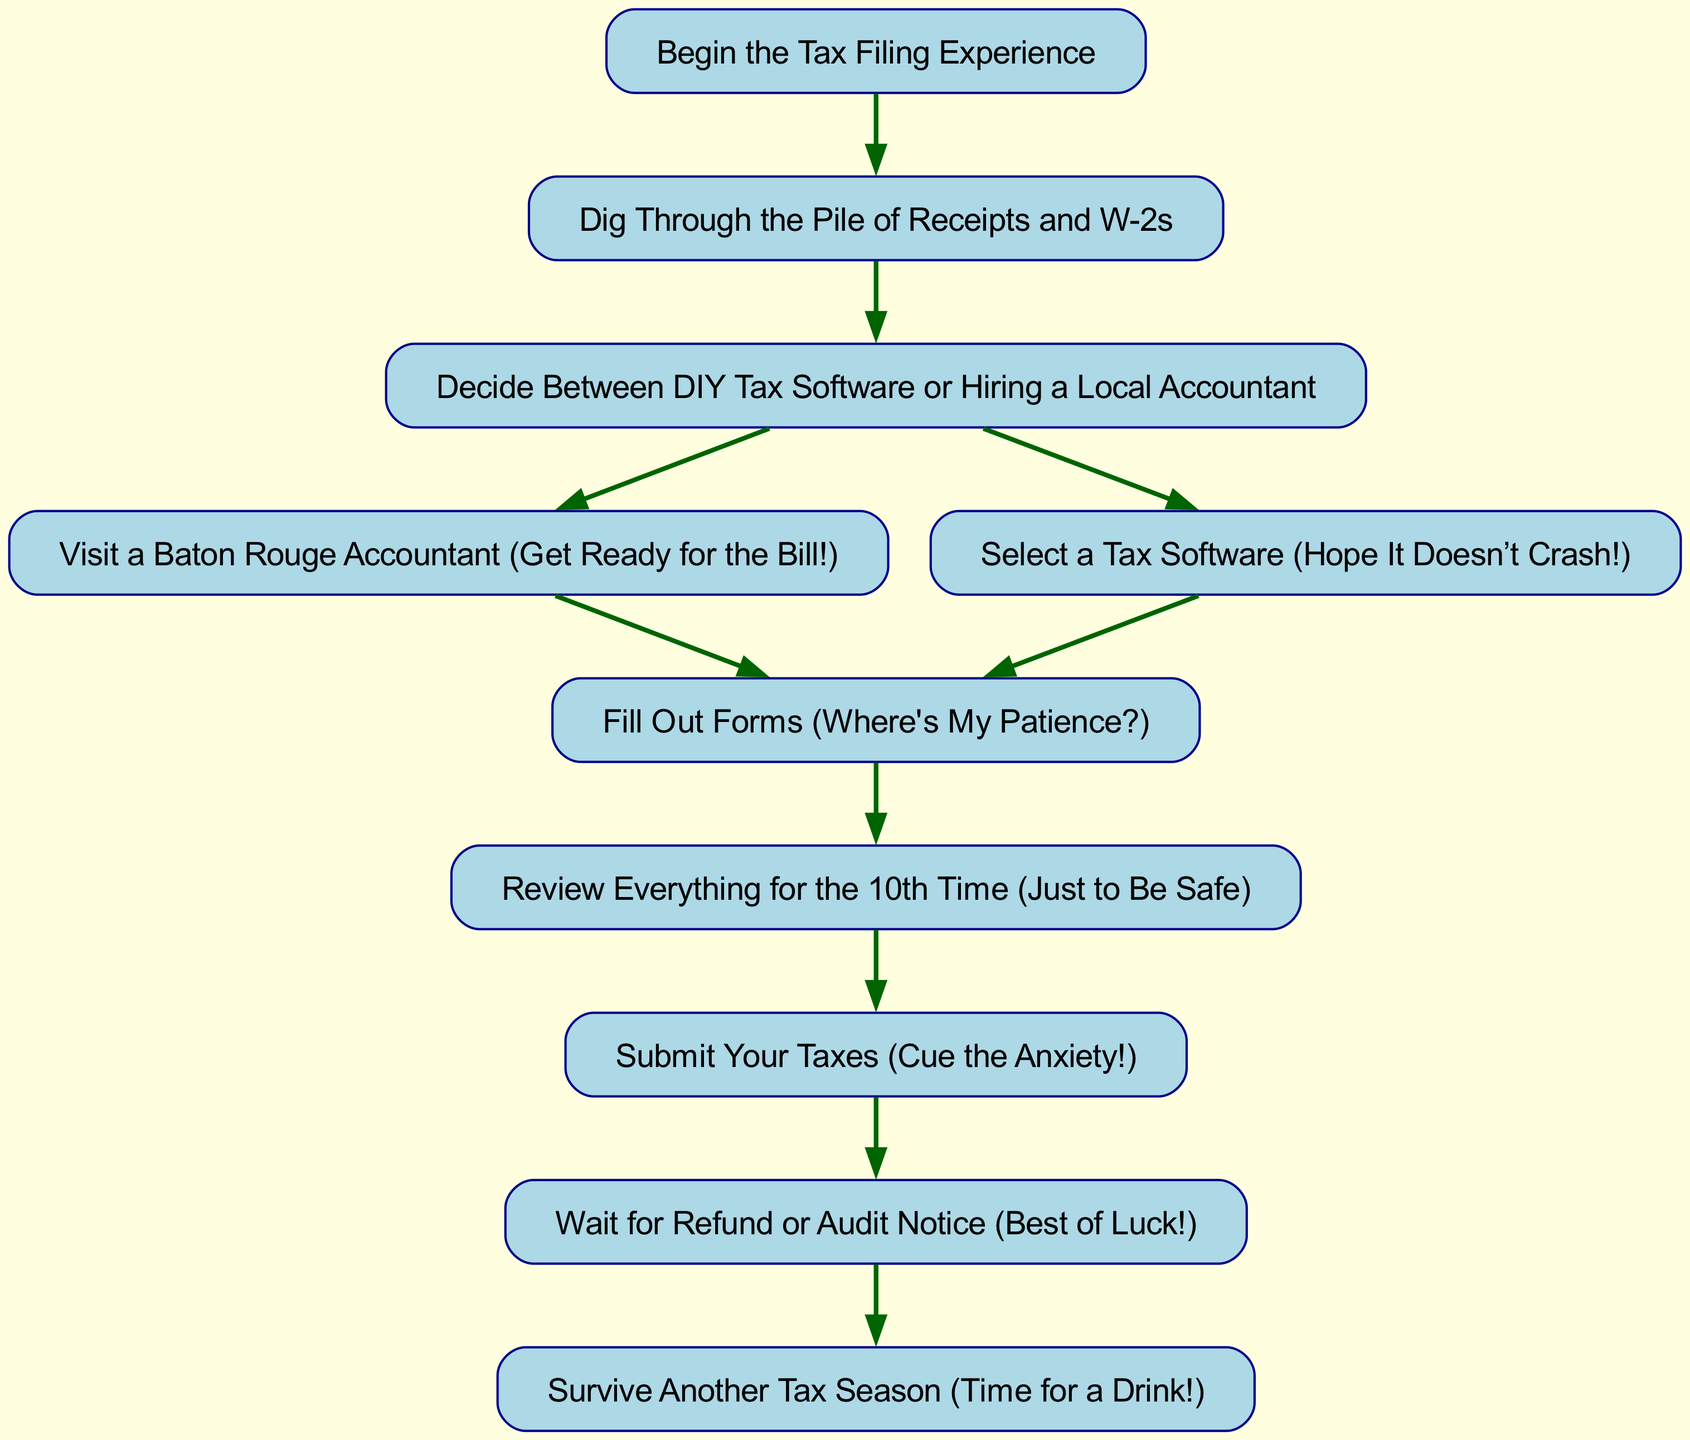What is the first step in the tax filing process? The first step according to the flow chart is labeled "Begin the Tax Filing Experience." This is the starting node from which all processes branch out.
Answer: Begin the Tax Filing Experience How many main methods are there to file taxes after gathering documents? After gathering documents, the process directs to a decision point labeled "Decide Between DIY Tax Software or Hiring a Local Accountant." This indicates there are two main methods to choose from.
Answer: Two What comes immediately after filling out forms? The flow chart indicates that after the "Fill Out Forms" step, the next step is "Review Everything for the 10th Time." This is a sequential flow in the process.
Answer: Review Everything for the 10th Time Which step indicates a high level of anxiety? The step labeled "Submit Your Taxes" includes the phrase "Cue the Anxiety!" This implies that it is specifically associated with the feeling of anxiety during the tax filing experience.
Answer: Submit Your Taxes How do you get from choosing a method to filling out forms if you choose a local accountant? The flow chart specifies that if you choose to visit a Baton Rouge accountant, you will then proceed to “Fill Out Forms.” This shows a direct path from one node to the next.
Answer: Fill Out Forms What is the last step in the tax filing experience? The final node in the flow chart is "Survive Another Tax Season (Time for a Drink!)," which concludes the entire process of tax filing.
Answer: Survive Another Tax Season (Time for a Drink!) What happens after submitting your taxes? After the "Submit Your Taxes" step, the flow chart shows that you will "Wait for Refund or Audit Notice." This indicates the next phase after submission.
Answer: Wait for Refund or Audit Notice If one starts with gathering documents, how many total steps are there to the final step? Counting all the steps from "Gather Documents" to "Survive Another Tax Season," including the starting point, there are seven steps outlined in the flowchart leading to the final outcome.
Answer: Seven 